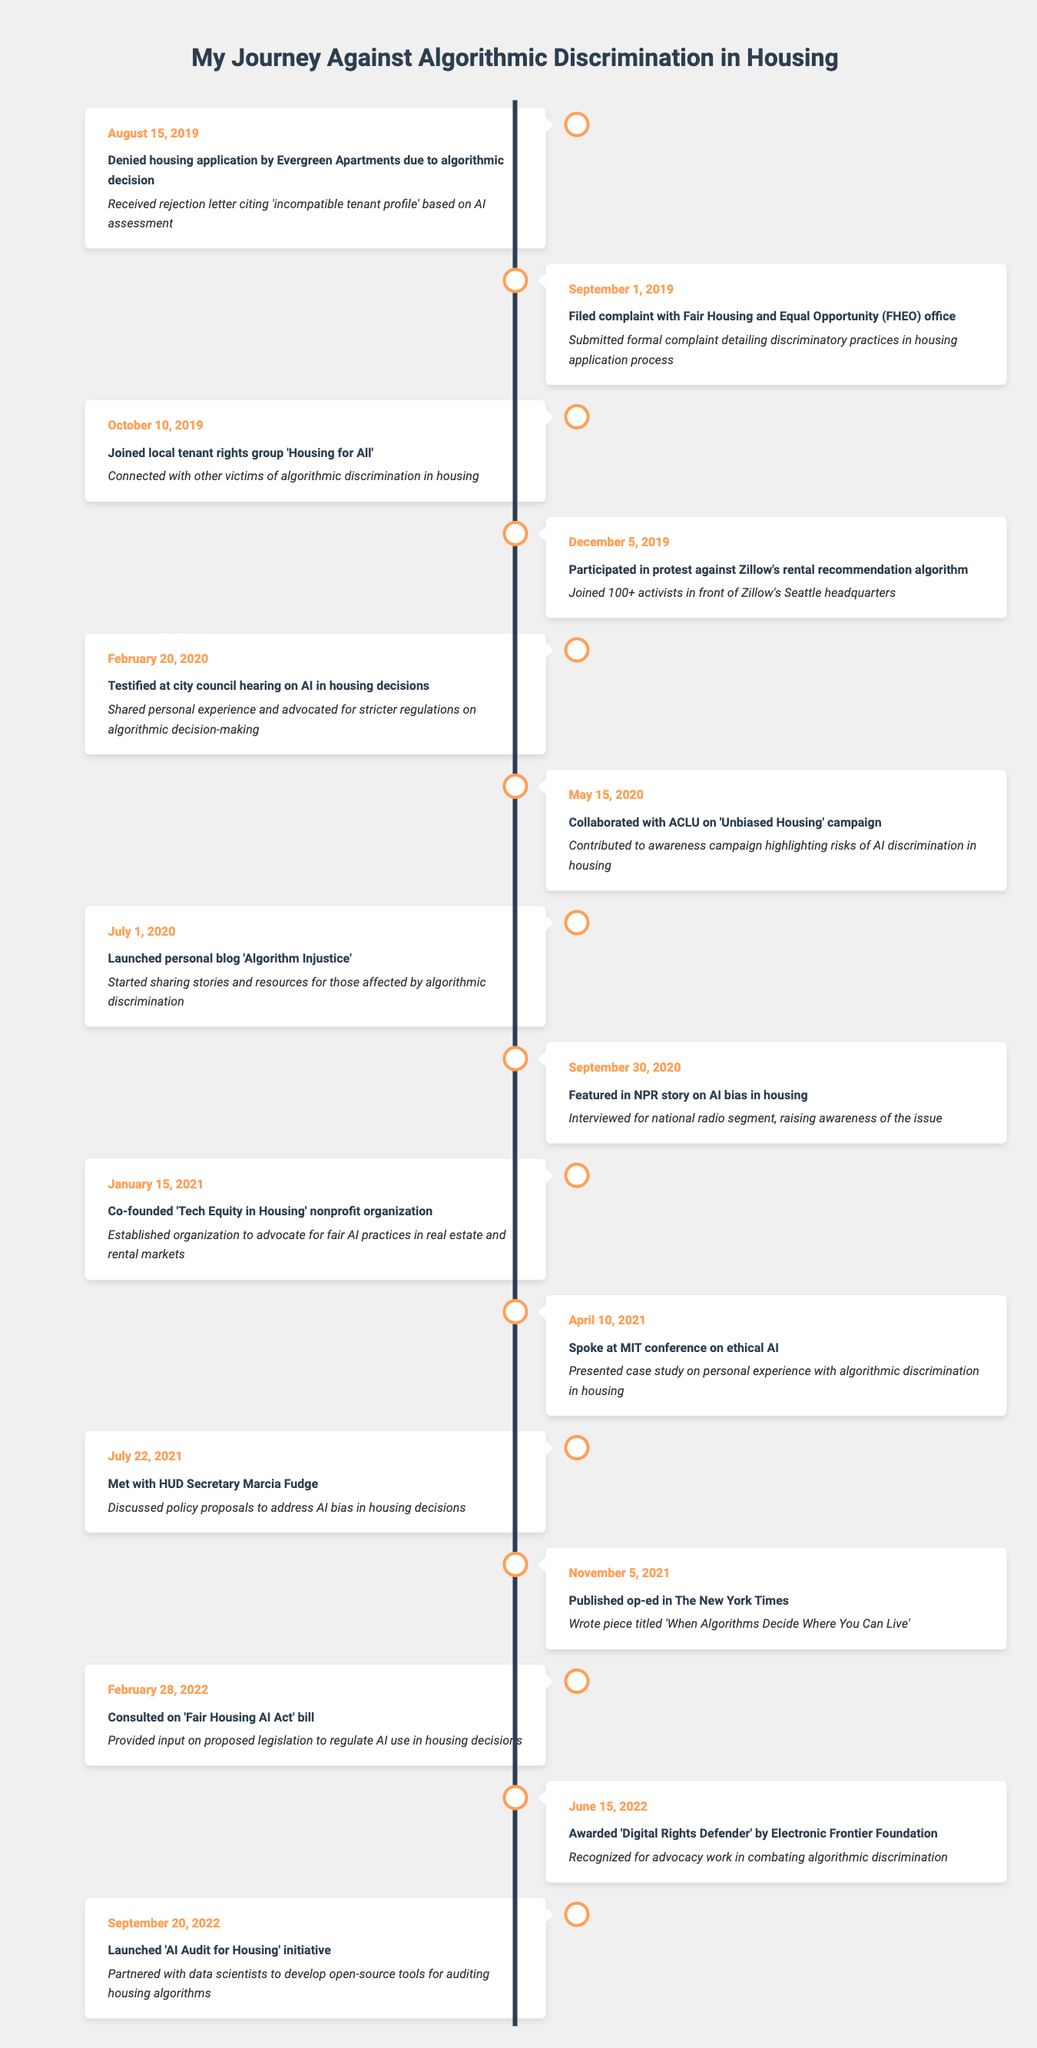What event occurred on August 15, 2019? The event on August 15, 2019, was the denial of a housing application by Evergreen Apartments due to an algorithmic decision. This is found at the beginning of the timeline.
Answer: Denied housing application by Evergreen Apartments due to algorithmic decision How many days passed between the denial of housing application and the filing of a complaint? The denial occurred on August 15, 2019, and the complaint was filed on September 1, 2019. Counting the days in between gives us 17 days.
Answer: 17 days Was there a protest involving more than 100 activists? Yes, the protest against Zillow's rental recommendation algorithm on December 5, 2019, involved over 100 activists. This is explicitly mentioned in the event description.
Answer: Yes What was the purpose of launching the 'AI Audit for Housing' initiative? The 'AI Audit for Housing' initiative, launched on September 20, 2022, aimed to develop open-source tools for auditing housing algorithms. This information is stated in the corresponding event description.
Answer: To develop open-source tools for auditing housing algorithms Which organization did you collaborate with on the 'Unbiased Housing' campaign? The collaboration was with the ACLU on May 15, 2020. This is detailed in the description for the corresponding event.
Answer: ACLU How many events in the timeline include the mention of collaboration? There are two events that mention collaboration: working with the ACLU on May 15, 2020, and co-founding the 'Tech Equity in Housing' nonprofit on January 15, 2021.
Answer: 2 events When did you testify at a city council hearing, and what was the focus? You testified on February 20, 2020, focusing on advocating for stricter regulations on algorithmic decision-making in housing. This is outlined in the event description for that date.
Answer: February 20, 2020, focus on stricter regulations What recognition did you receive in June 2022, and by which organization? In June 2022, you were awarded the 'Digital Rights Defender' by the Electronic Frontier Foundation for your advocacy work. This is noted in the timeline entry for June 15, 2022.
Answer: 'Digital Rights Defender' by Electronic Frontier Foundation How many months were there between the launch of your blog and the publication of an op-ed in The New York Times? The blog 'Algorithm Injustice' was launched on July 1, 2020, and the op-ed was published on November 5, 2021. The difference is 16 months between these two events.
Answer: 16 months 